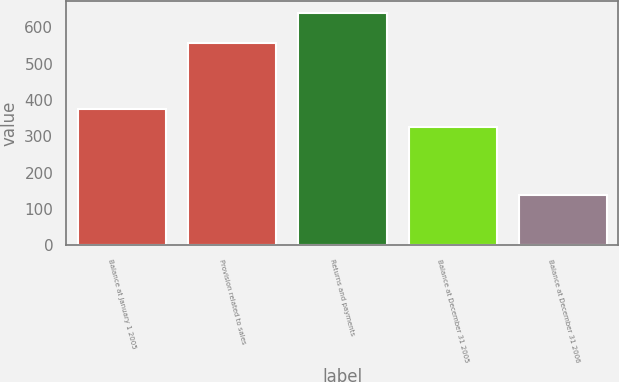Convert chart. <chart><loc_0><loc_0><loc_500><loc_500><bar_chart><fcel>Balance at January 1 2005<fcel>Provision related to sales<fcel>Returns and payments<fcel>Balance at December 31 2005<fcel>Balance at December 31 2006<nl><fcel>376.4<fcel>558<fcel>641<fcel>326<fcel>137<nl></chart> 